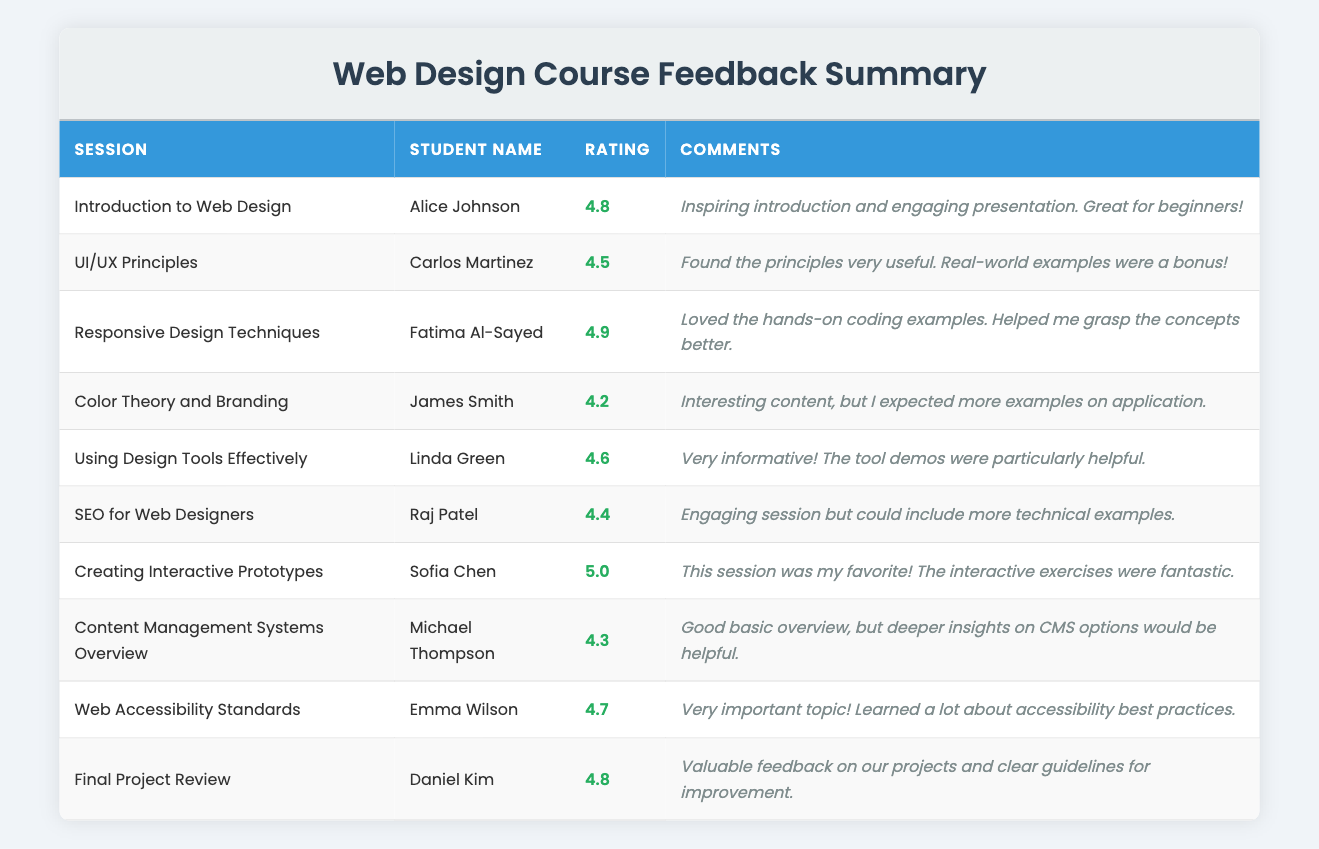What's the highest rating given in the course sessions? The highest rating in the table is shown for the session "Creating Interactive Prototypes," where Sofia Chen gave a rating of 5.0.
Answer: 5.0 Which student provided feedback for the "Color Theory and Branding" session? The feedback for the "Color Theory and Branding" session was provided by James Smith.
Answer: James Smith How many sessions received a rating above 4.5? The sessions with ratings above 4.5 are "Introduction to Web Design," "Responsive Design Techniques," "Creating Interactive Prototypes," and "Web Accessibility Standards," totaling four sessions.
Answer: 4 What is the average rating of all sessions in the course? To find the average rating, sum the ratings (4.8 + 4.5 + 4.9 + 4.2 + 4.6 + 4.4 + 5.0 + 4.3 + 4.7 + 4.8) = 48.2, and then divide by the number of sessions (10). Thus, the average rating is 48.2 / 10 = 4.82.
Answer: 4.82 Did Raj Patel find the "SEO for Web Designers" session helpful? Raj Patel provided a rating of 4.4 for the session, indicating it was engaging but suggested including more technical examples, which suggests he found it somewhat helpful but lacking.
Answer: No What are the comments made by Fatima Al-Sayed for her session? Fatima Al-Sayed commented on the "Responsive Design Techniques" session that she loved the hands-on coding examples, which helped her grasp the concepts better.
Answer: Loved the hands-on coding examples Is there a session that was rated lower than 4.3? Reviewing the ratings, the lowest rating was 4.2 for the "Color Theory and Branding" session, which is lower than 4.3.
Answer: Yes Which session had the most positive feedback based on comments? The "Creating Interactive Prototypes" session received the most positive feedback as Sofia Chen described it as her favorite with fantastic interactive exercises, indicating a high level of satisfaction.
Answer: Creating Interactive Prototypes How does the rating of "Using Design Tools Effectively" compare to the average rating? "Using Design Tools Effectively" has a rating of 4.6, which is above the average rating of 4.82, indicating it’s slightly below the average but still good.
Answer: Below average What trend can be observed in the ratings based on the session topic? Generally, technical sessions like "Responsive Design Techniques" and practical sessions like "Creating Interactive Prototypes" tend to receive higher ratings, while less practical sessions such as "Color Theory and Branding" received lower ratings.
Answer: Technical sessions rated higher 